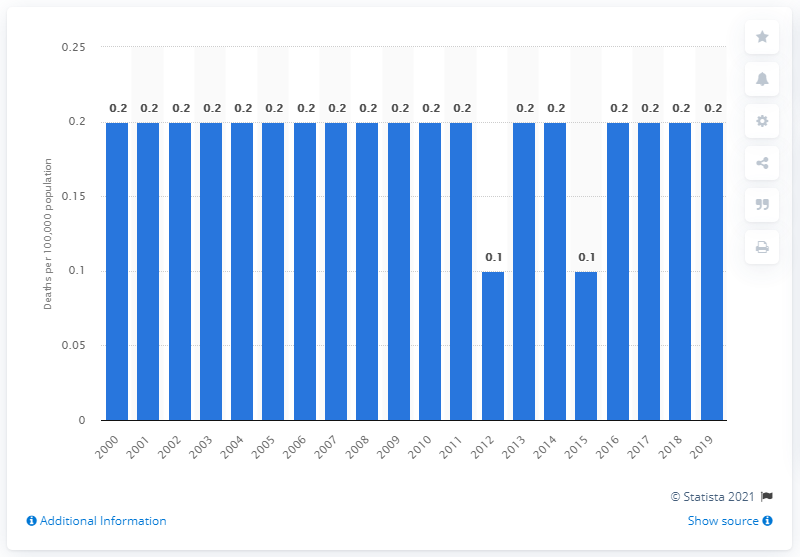Highlight a few significant elements in this photo. Since the year 2000, the death rate from meningitis in Canada has remained stable. 